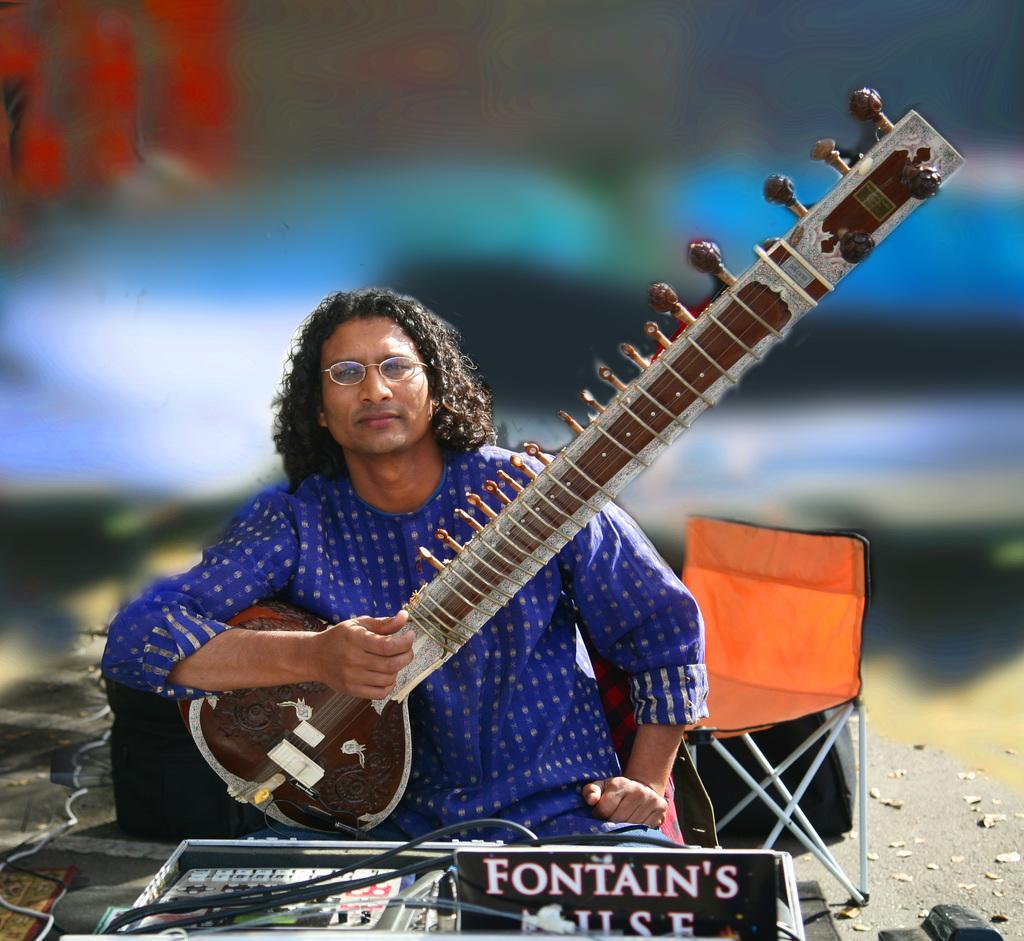Describe this image in one or two sentences. In this image I can see a person wearing blue colored dress is holding a musical instrument in his hand. I can see few objects in front of him and a chair which is orange and white in color. I can see the blurry background. 